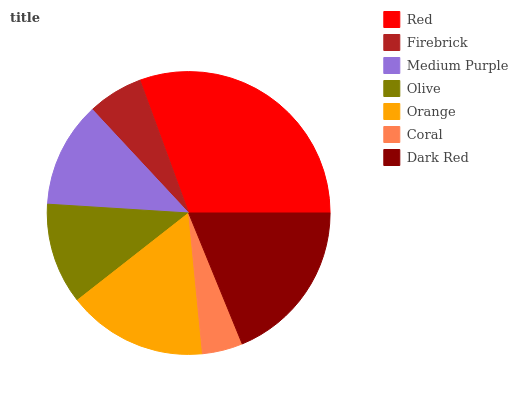Is Coral the minimum?
Answer yes or no. Yes. Is Red the maximum?
Answer yes or no. Yes. Is Firebrick the minimum?
Answer yes or no. No. Is Firebrick the maximum?
Answer yes or no. No. Is Red greater than Firebrick?
Answer yes or no. Yes. Is Firebrick less than Red?
Answer yes or no. Yes. Is Firebrick greater than Red?
Answer yes or no. No. Is Red less than Firebrick?
Answer yes or no. No. Is Medium Purple the high median?
Answer yes or no. Yes. Is Medium Purple the low median?
Answer yes or no. Yes. Is Red the high median?
Answer yes or no. No. Is Firebrick the low median?
Answer yes or no. No. 